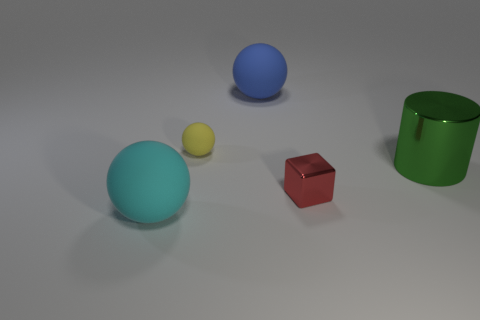Subtract all blue rubber balls. How many balls are left? 2 Subtract 1 balls. How many balls are left? 2 Add 3 rubber things. How many objects exist? 8 Subtract all blue spheres. How many spheres are left? 2 Subtract all cylinders. How many objects are left? 4 Subtract 1 red blocks. How many objects are left? 4 Subtract all purple spheres. Subtract all gray blocks. How many spheres are left? 3 Subtract all yellow matte blocks. Subtract all small yellow rubber things. How many objects are left? 4 Add 3 large spheres. How many large spheres are left? 5 Add 3 big cyan matte things. How many big cyan matte things exist? 4 